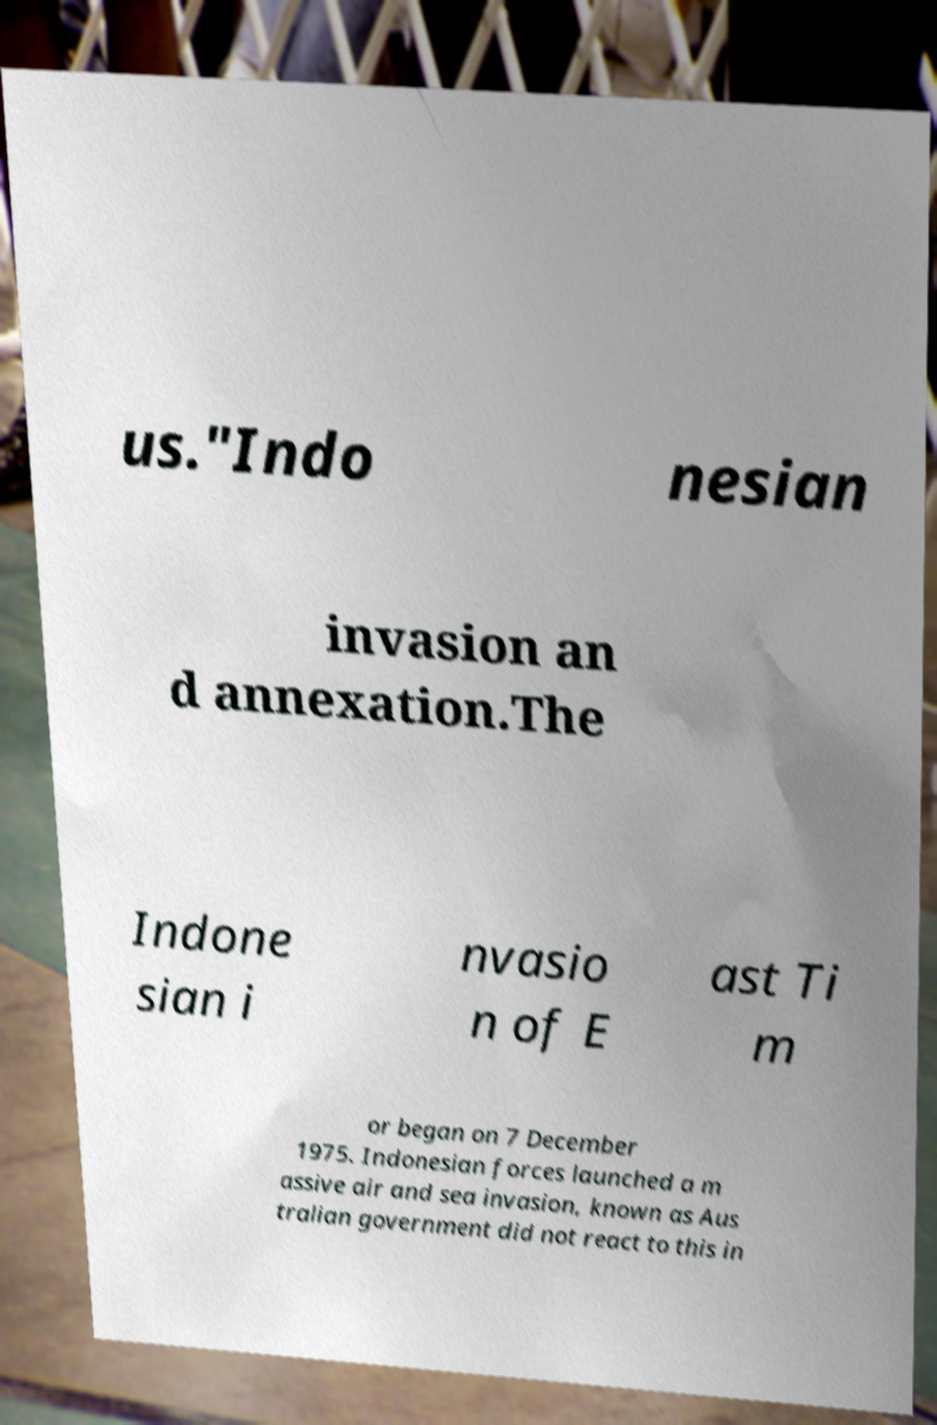Could you assist in decoding the text presented in this image and type it out clearly? us."Indo nesian invasion an d annexation.The Indone sian i nvasio n of E ast Ti m or began on 7 December 1975. Indonesian forces launched a m assive air and sea invasion, known as Aus tralian government did not react to this in 